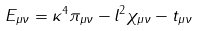Convert formula to latex. <formula><loc_0><loc_0><loc_500><loc_500>E _ { \mu \nu } = \kappa ^ { 4 } \pi _ { \mu \nu } - l ^ { 2 } \chi _ { \mu \nu } - t _ { \mu \nu }</formula> 